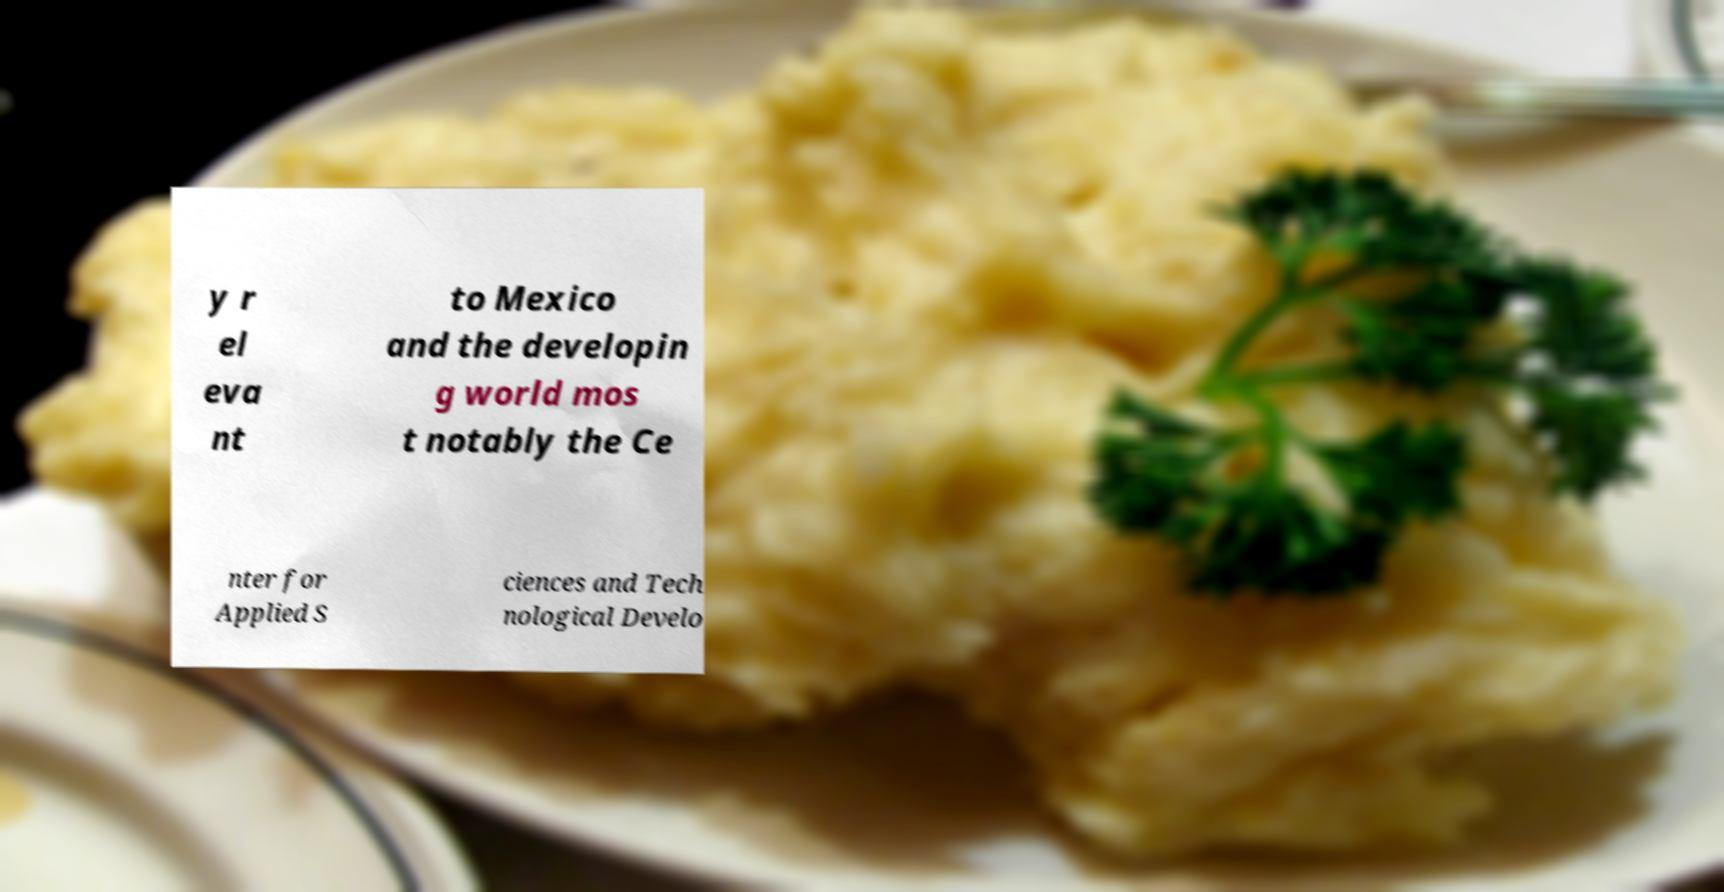Can you accurately transcribe the text from the provided image for me? y r el eva nt to Mexico and the developin g world mos t notably the Ce nter for Applied S ciences and Tech nological Develo 